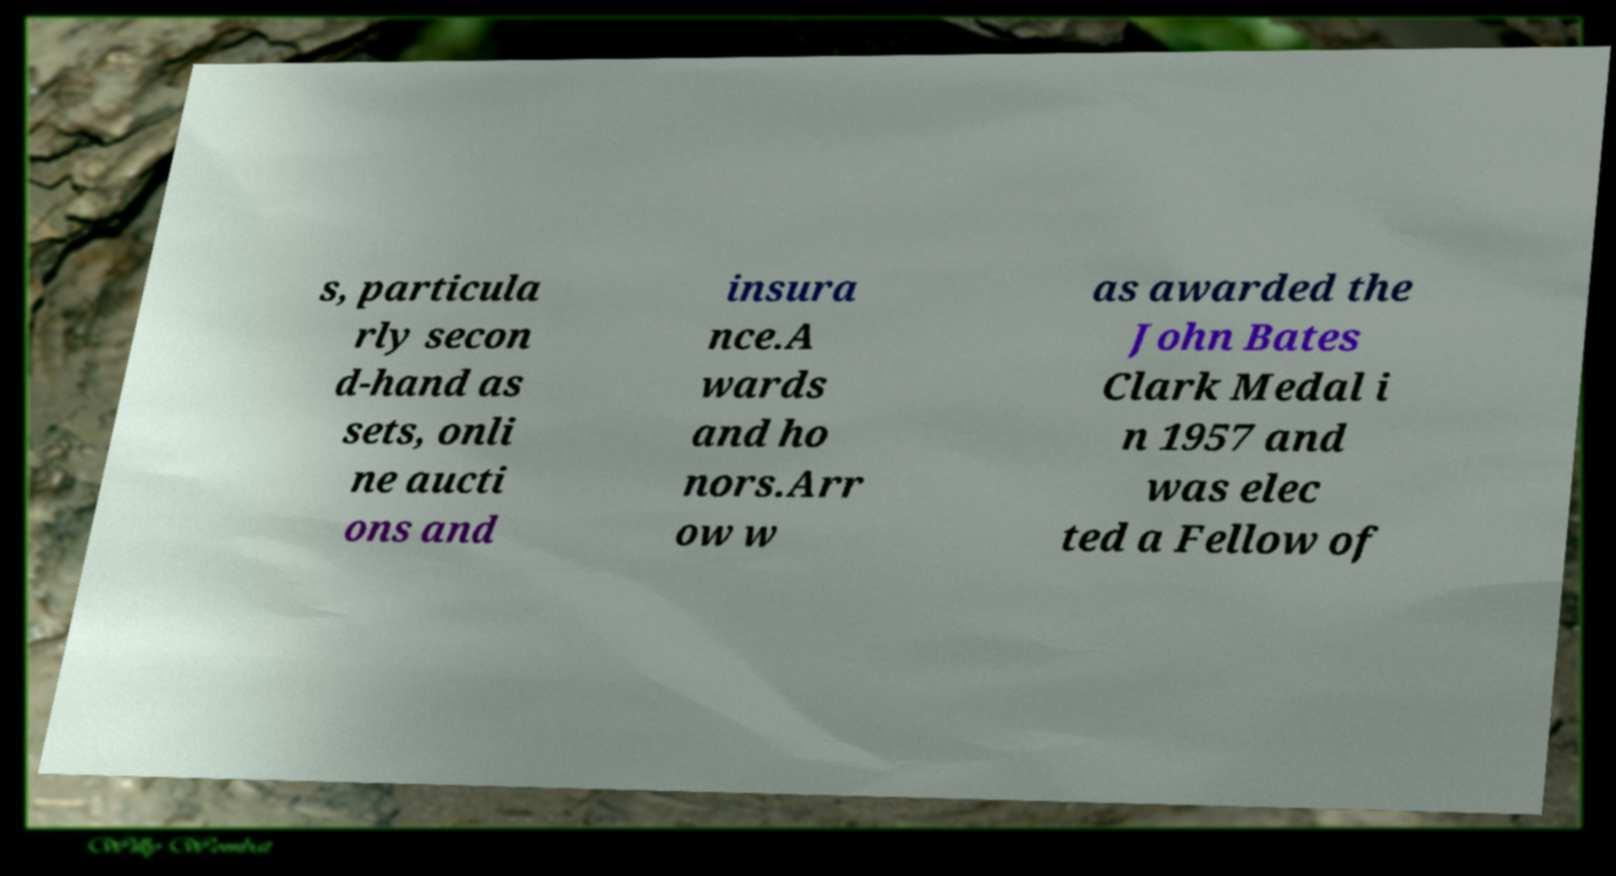Please identify and transcribe the text found in this image. s, particula rly secon d-hand as sets, onli ne aucti ons and insura nce.A wards and ho nors.Arr ow w as awarded the John Bates Clark Medal i n 1957 and was elec ted a Fellow of 